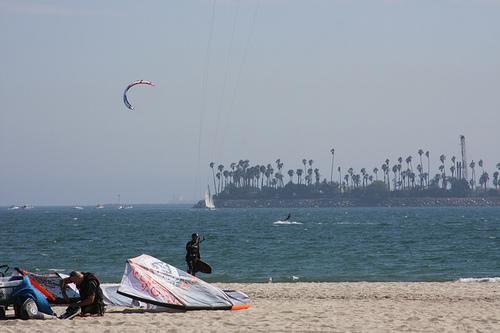What is the weather like?
Give a very brief answer. Sunny. How many types of water sports are depicted?
Short answer required. 2. Are those palm trees?
Write a very short answer. Yes. 